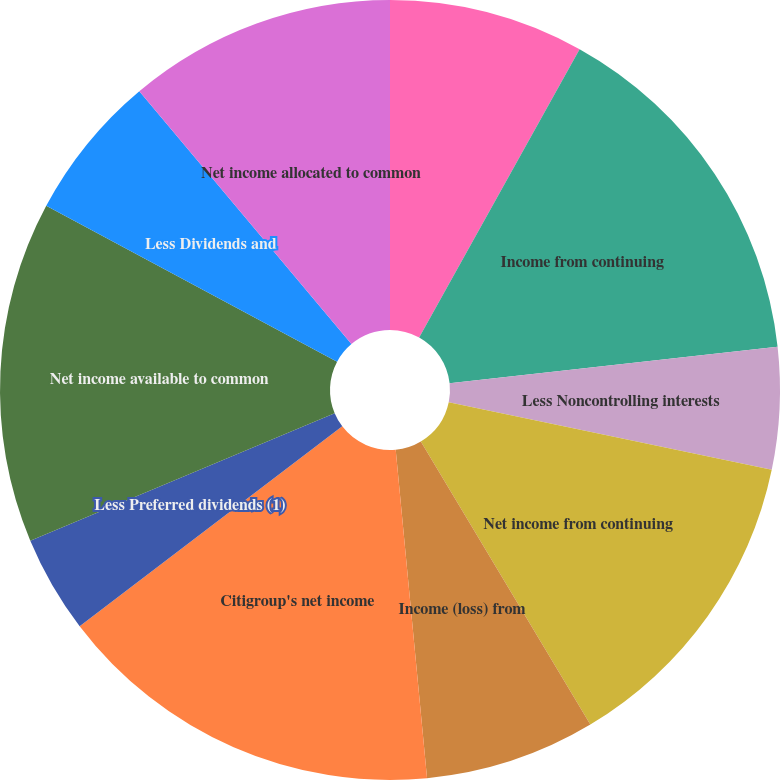Convert chart to OTSL. <chart><loc_0><loc_0><loc_500><loc_500><pie_chart><fcel>In millions except per-share<fcel>Income from continuing<fcel>Less Noncontrolling interests<fcel>Net income from continuing<fcel>Income (loss) from<fcel>Citigroup's net income<fcel>Less Preferred dividends (1)<fcel>Net income available to common<fcel>Less Dividends and<fcel>Net income allocated to common<nl><fcel>8.08%<fcel>15.15%<fcel>5.05%<fcel>13.13%<fcel>7.07%<fcel>16.16%<fcel>4.04%<fcel>14.14%<fcel>6.06%<fcel>11.11%<nl></chart> 